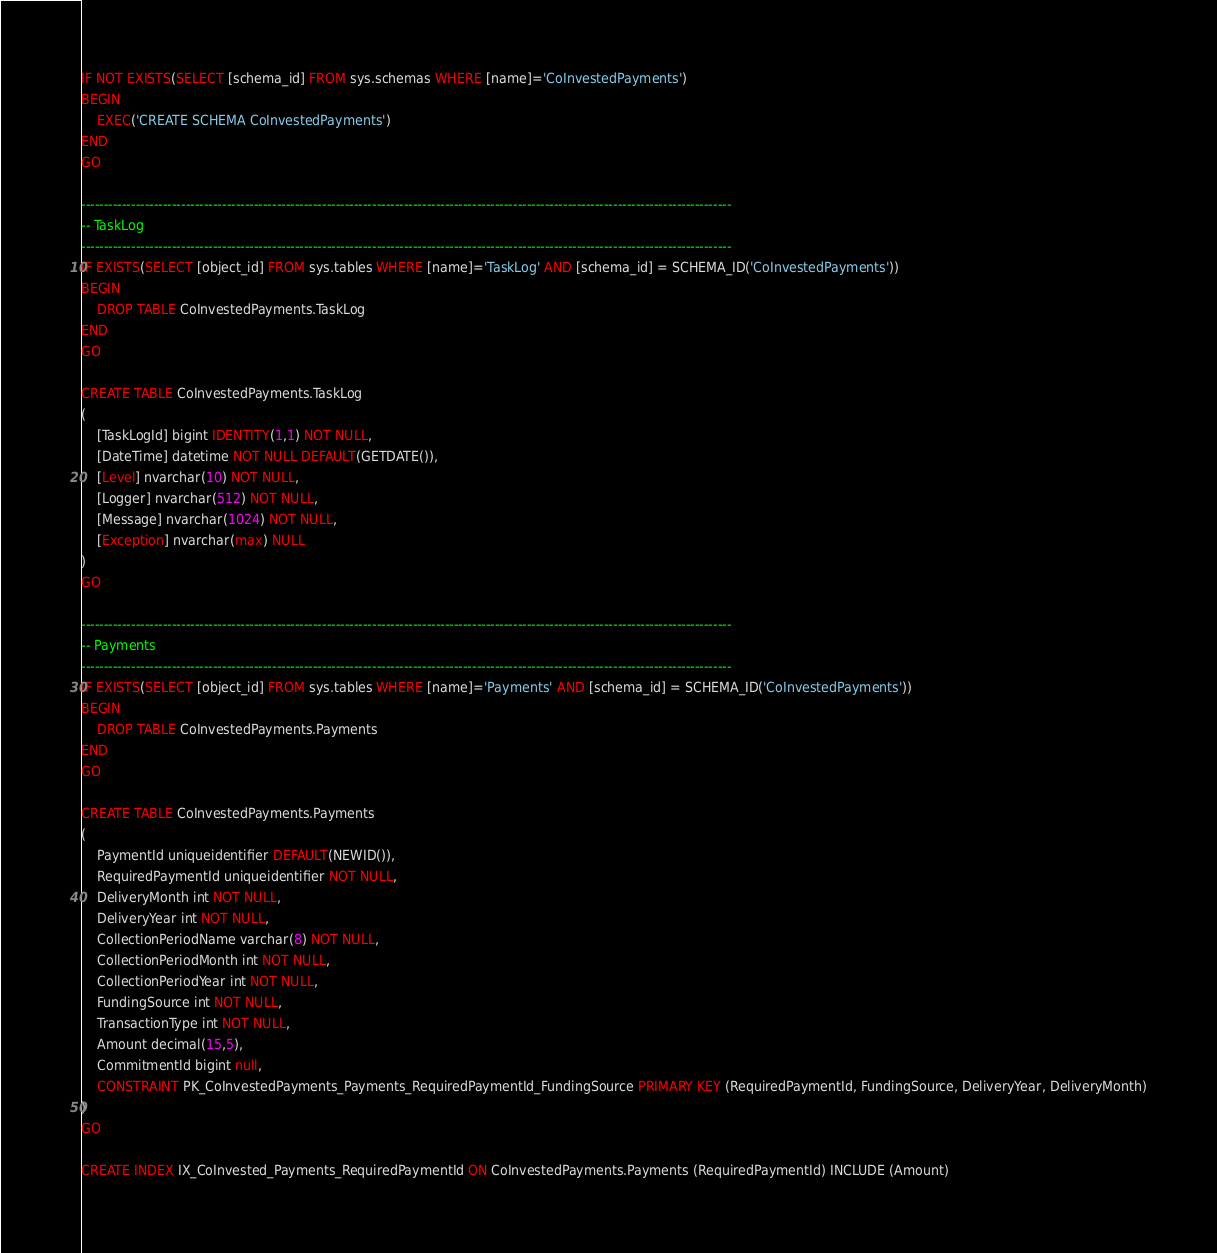Convert code to text. <code><loc_0><loc_0><loc_500><loc_500><_SQL_>IF NOT EXISTS(SELECT [schema_id] FROM sys.schemas WHERE [name]='CoInvestedPayments')
BEGIN
	EXEC('CREATE SCHEMA CoInvestedPayments')
END
GO

-----------------------------------------------------------------------------------------------------------------------------------------------
-- TaskLog
-----------------------------------------------------------------------------------------------------------------------------------------------
IF EXISTS(SELECT [object_id] FROM sys.tables WHERE [name]='TaskLog' AND [schema_id] = SCHEMA_ID('CoInvestedPayments'))
BEGIN
	DROP TABLE CoInvestedPayments.TaskLog
END
GO

CREATE TABLE CoInvestedPayments.TaskLog
(
	[TaskLogId] bigint IDENTITY(1,1) NOT NULL,
	[DateTime] datetime NOT NULL DEFAULT(GETDATE()),
	[Level] nvarchar(10) NOT NULL,
	[Logger] nvarchar(512) NOT NULL,
	[Message] nvarchar(1024) NOT NULL,
	[Exception] nvarchar(max) NULL
)
GO

-----------------------------------------------------------------------------------------------------------------------------------------------
-- Payments
-----------------------------------------------------------------------------------------------------------------------------------------------
IF EXISTS(SELECT [object_id] FROM sys.tables WHERE [name]='Payments' AND [schema_id] = SCHEMA_ID('CoInvestedPayments'))
BEGIN
	DROP TABLE CoInvestedPayments.Payments
END
GO

CREATE TABLE CoInvestedPayments.Payments
(
	PaymentId uniqueidentifier DEFAULT(NEWID()),
	RequiredPaymentId uniqueidentifier NOT NULL,
	DeliveryMonth int NOT NULL,
	DeliveryYear int NOT NULL,
	CollectionPeriodName varchar(8) NOT NULL,
	CollectionPeriodMonth int NOT NULL,
	CollectionPeriodYear int NOT NULL,
	FundingSource int NOT NULL,
	TransactionType int NOT NULL,
	Amount decimal(15,5),
	CommitmentId bigint null,
	CONSTRAINT PK_CoInvestedPayments_Payments_RequiredPaymentId_FundingSource PRIMARY KEY (RequiredPaymentId, FundingSource, DeliveryYear, DeliveryMonth)
)
GO

CREATE INDEX IX_CoInvested_Payments_RequiredPaymentId ON CoInvestedPayments.Payments (RequiredPaymentId) INCLUDE (Amount)
</code> 